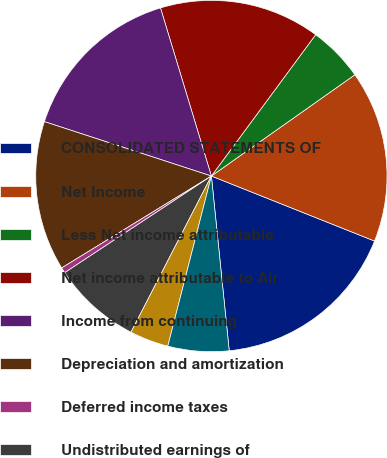Convert chart. <chart><loc_0><loc_0><loc_500><loc_500><pie_chart><fcel>CONSOLIDATED STATEMENTS OF<fcel>Net Income<fcel>Less Net income attributable<fcel>Net income attributable to Air<fcel>Income from continuing<fcel>Depreciation and amortization<fcel>Deferred income taxes<fcel>Undistributed earnings of<fcel>(Gain) Loss on sale of assets<fcel>Share-based compensation<nl><fcel>17.34%<fcel>15.81%<fcel>5.1%<fcel>14.79%<fcel>15.3%<fcel>13.77%<fcel>0.51%<fcel>8.16%<fcel>3.57%<fcel>5.61%<nl></chart> 